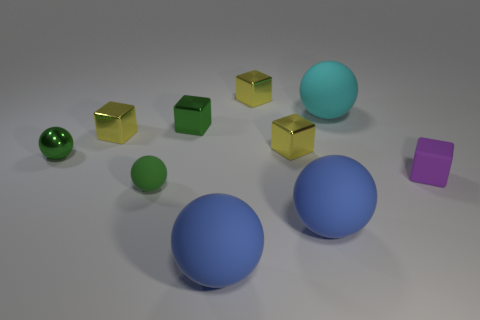How many yellow cubes must be subtracted to get 1 yellow cubes? 2 Subtract all small balls. How many balls are left? 3 Subtract all green balls. How many balls are left? 3 Subtract 0 blue blocks. How many objects are left? 10 Subtract 4 spheres. How many spheres are left? 1 Subtract all cyan spheres. Subtract all gray cubes. How many spheres are left? 4 Subtract all yellow cylinders. How many blue spheres are left? 2 Subtract all green things. Subtract all small shiny blocks. How many objects are left? 3 Add 8 metal spheres. How many metal spheres are left? 9 Add 1 spheres. How many spheres exist? 6 